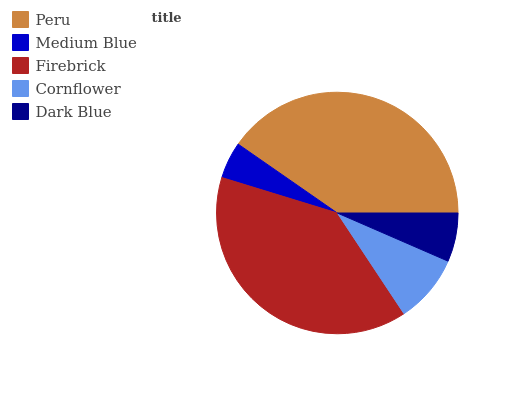Is Medium Blue the minimum?
Answer yes or no. Yes. Is Peru the maximum?
Answer yes or no. Yes. Is Firebrick the minimum?
Answer yes or no. No. Is Firebrick the maximum?
Answer yes or no. No. Is Firebrick greater than Medium Blue?
Answer yes or no. Yes. Is Medium Blue less than Firebrick?
Answer yes or no. Yes. Is Medium Blue greater than Firebrick?
Answer yes or no. No. Is Firebrick less than Medium Blue?
Answer yes or no. No. Is Cornflower the high median?
Answer yes or no. Yes. Is Cornflower the low median?
Answer yes or no. Yes. Is Medium Blue the high median?
Answer yes or no. No. Is Peru the low median?
Answer yes or no. No. 